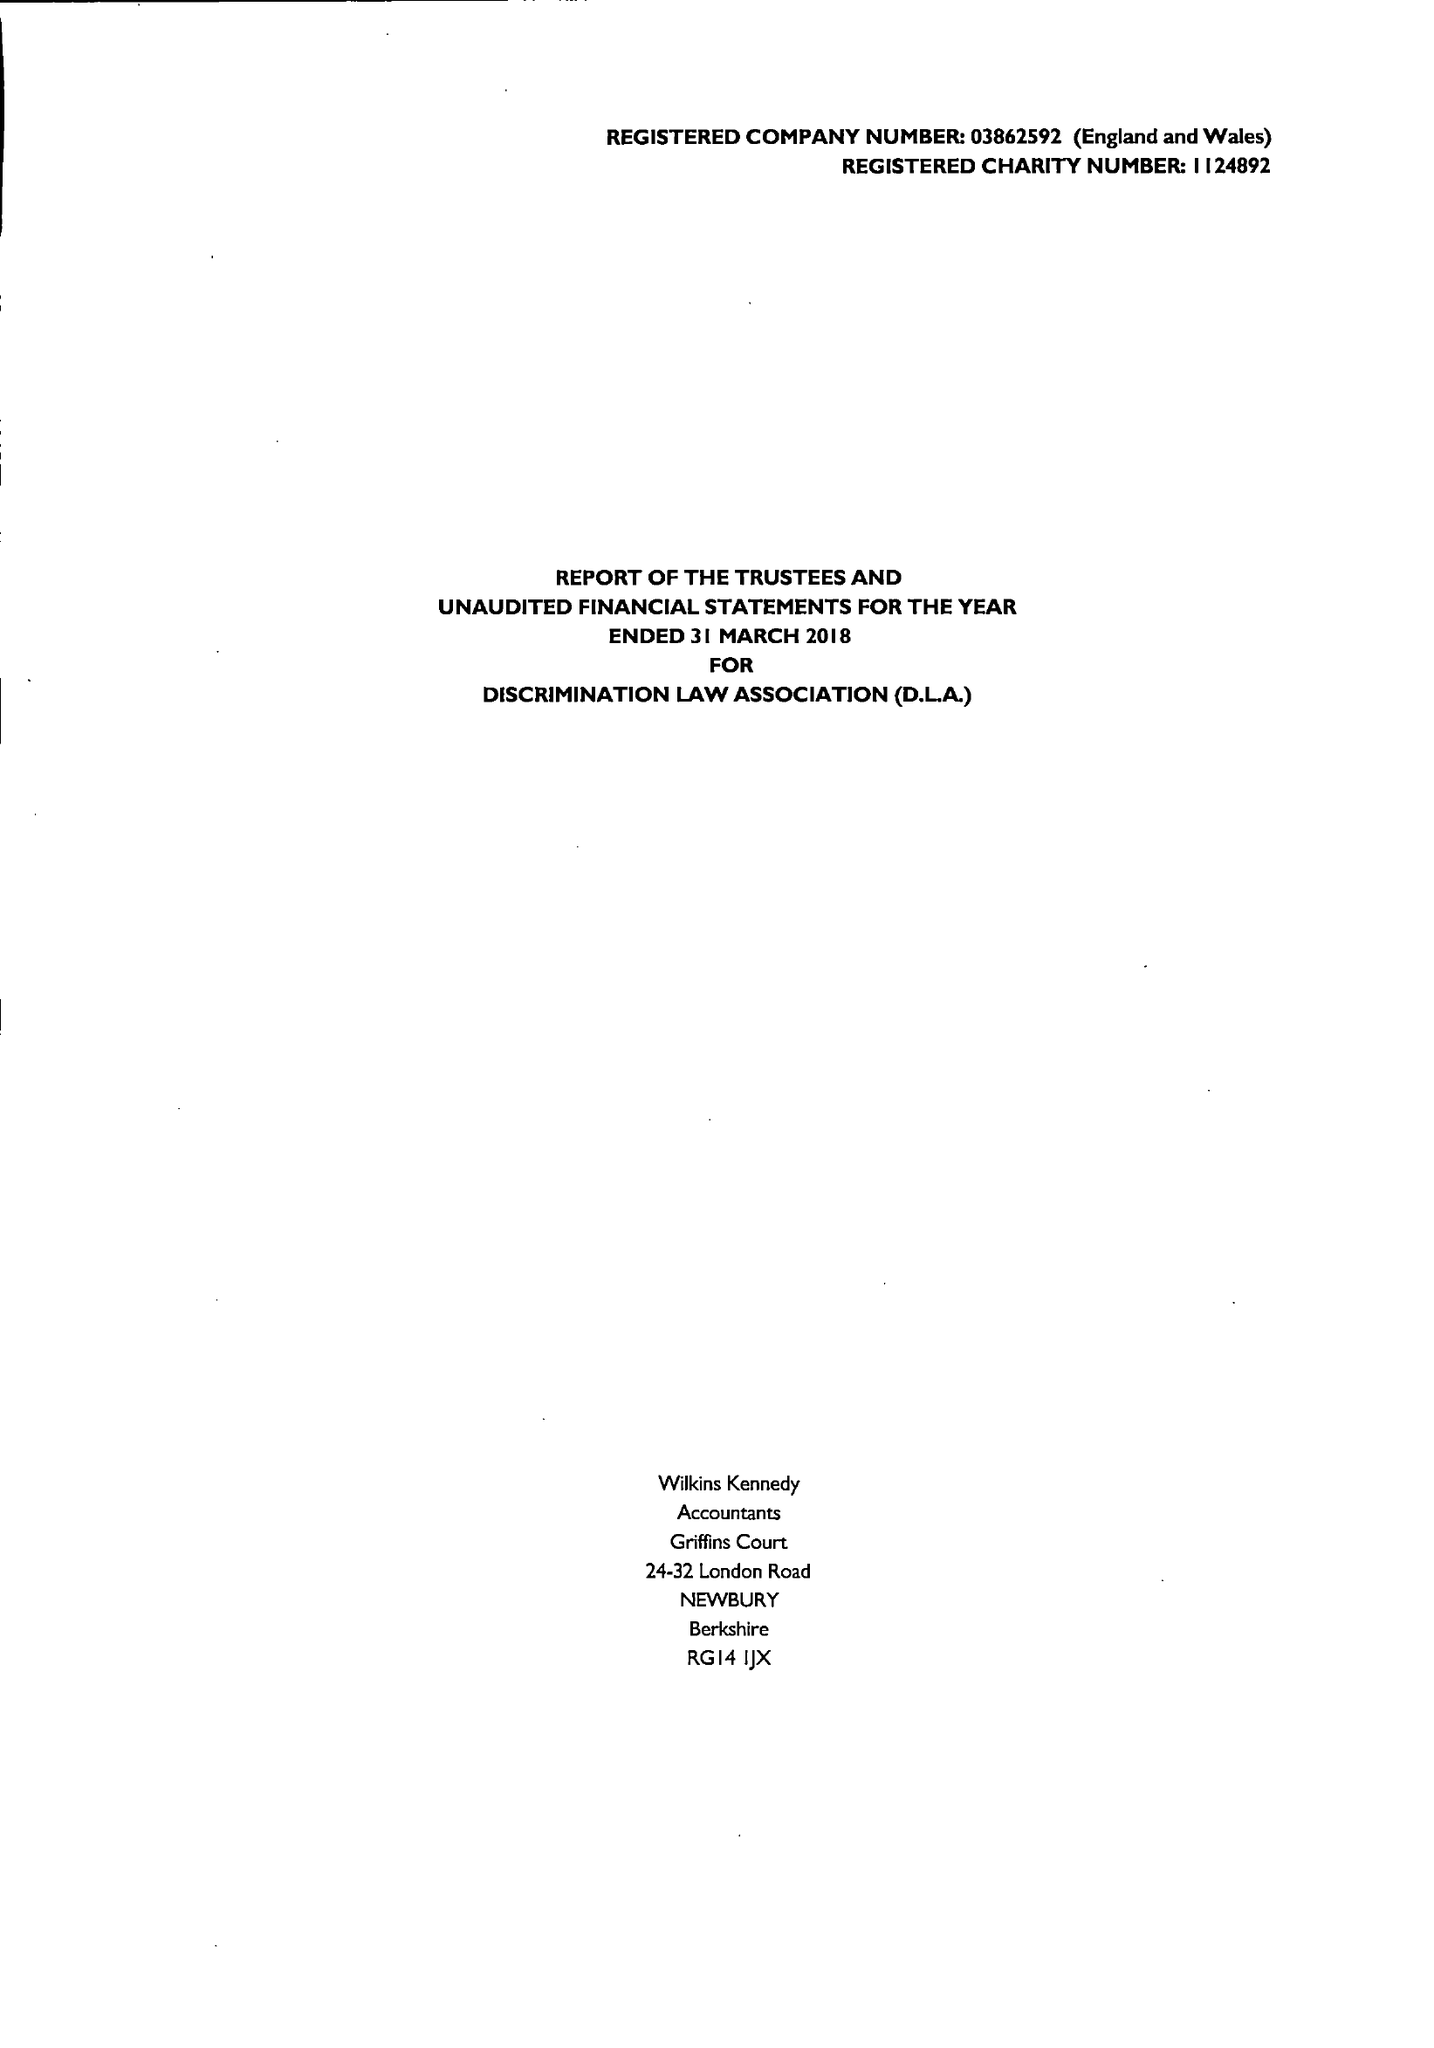What is the value for the report_date?
Answer the question using a single word or phrase. 2018-03-31 